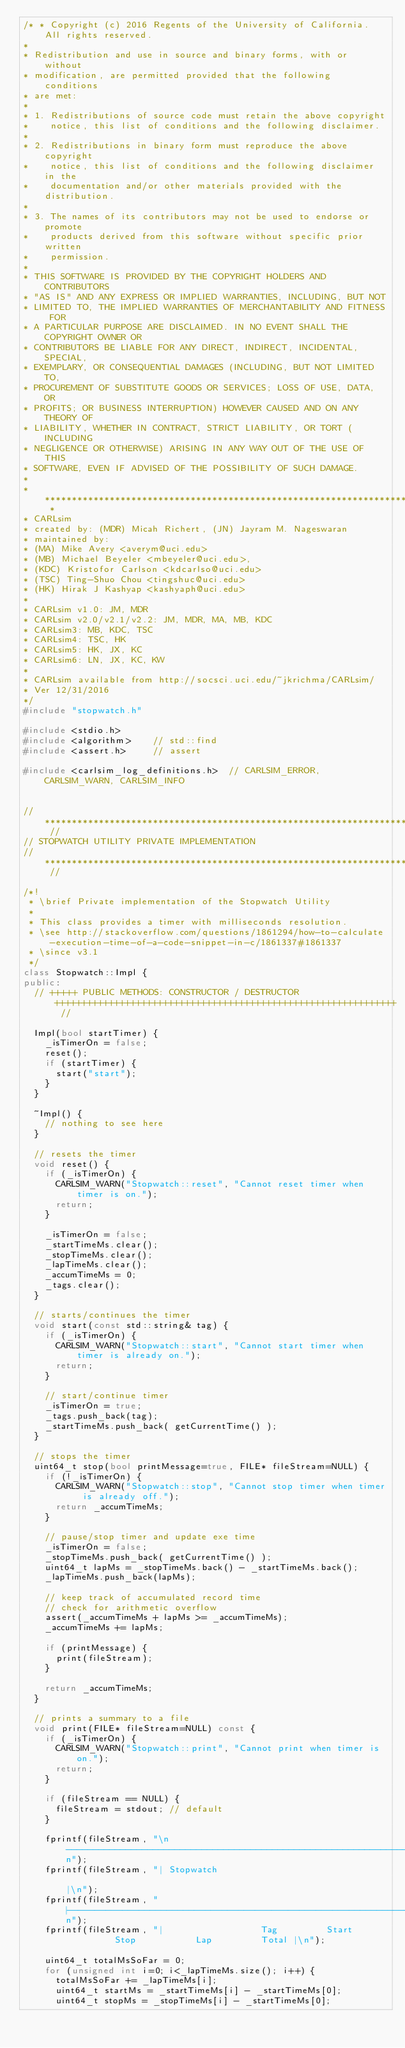Convert code to text. <code><loc_0><loc_0><loc_500><loc_500><_C++_>/* * Copyright (c) 2016 Regents of the University of California. All rights reserved.
*
* Redistribution and use in source and binary forms, with or without
* modification, are permitted provided that the following conditions
* are met:
*
* 1. Redistributions of source code must retain the above copyright
*    notice, this list of conditions and the following disclaimer.
*
* 2. Redistributions in binary form must reproduce the above copyright
*    notice, this list of conditions and the following disclaimer in the
*    documentation and/or other materials provided with the distribution.
*
* 3. The names of its contributors may not be used to endorse or promote
*    products derived from this software without specific prior written
*    permission.
*
* THIS SOFTWARE IS PROVIDED BY THE COPYRIGHT HOLDERS AND CONTRIBUTORS
* "AS IS" AND ANY EXPRESS OR IMPLIED WARRANTIES, INCLUDING, BUT NOT
* LIMITED TO, THE IMPLIED WARRANTIES OF MERCHANTABILITY AND FITNESS FOR
* A PARTICULAR PURPOSE ARE DISCLAIMED. IN NO EVENT SHALL THE COPYRIGHT OWNER OR
* CONTRIBUTORS BE LIABLE FOR ANY DIRECT, INDIRECT, INCIDENTAL, SPECIAL,
* EXEMPLARY, OR CONSEQUENTIAL DAMAGES (INCLUDING, BUT NOT LIMITED TO,
* PROCUREMENT OF SUBSTITUTE GOODS OR SERVICES; LOSS OF USE, DATA, OR
* PROFITS; OR BUSINESS INTERRUPTION) HOWEVER CAUSED AND ON ANY THEORY OF
* LIABILITY, WHETHER IN CONTRACT, STRICT LIABILITY, OR TORT (INCLUDING
* NEGLIGENCE OR OTHERWISE) ARISING IN ANY WAY OUT OF THE USE OF THIS
* SOFTWARE, EVEN IF ADVISED OF THE POSSIBILITY OF SUCH DAMAGE.
*
* *********************************************************************************************** *
* CARLsim
* created by: (MDR) Micah Richert, (JN) Jayram M. Nageswaran
* maintained by:
* (MA) Mike Avery <averym@uci.edu>
* (MB) Michael Beyeler <mbeyeler@uci.edu>,
* (KDC) Kristofor Carlson <kdcarlso@uci.edu>
* (TSC) Ting-Shuo Chou <tingshuc@uci.edu>
* (HK) Hirak J Kashyap <kashyaph@uci.edu>
*
* CARLsim v1.0: JM, MDR
* CARLsim v2.0/v2.1/v2.2: JM, MDR, MA, MB, KDC
* CARLsim3: MB, KDC, TSC
* CARLsim4: TSC, HK
* CARLsim5: HK, JX, KC
* CARLsim6: LN, JX, KC, KW
*
* CARLsim available from http://socsci.uci.edu/~jkrichma/CARLsim/
* Ver 12/31/2016
*/
#include "stopwatch.h"

#include <stdio.h>
#include <algorithm>		// std::find
#include <assert.h>			// assert

#include <carlsim_log_definitions.h>	// CARLSIM_ERROR, CARLSIM_WARN, CARLSIM_INFO


// ****************************************************************************************************************** //
// STOPWATCH UTILITY PRIVATE IMPLEMENTATION
// ****************************************************************************************************************** //

/*!
 * \brief Private implementation of the Stopwatch Utility
 *
 * This class provides a timer with milliseconds resolution.
 * \see http://stackoverflow.com/questions/1861294/how-to-calculate-execution-time-of-a-code-snippet-in-c/1861337#1861337
 * \since v3.1
 */
class Stopwatch::Impl {
public:
	// +++++ PUBLIC METHODS: CONSTRUCTOR / DESTRUCTOR +++++++++++++++++++++++++++++++++++++++++++++++++++++++++++++++ //

	Impl(bool startTimer) {
		_isTimerOn = false;
		reset();
		if (startTimer) {
			start("start");
		}
	}

	~Impl() {
		// nothing to see here
	}

	// resets the timer
	void reset() {
		if (_isTimerOn) {
			CARLSIM_WARN("Stopwatch::reset", "Cannot reset timer when timer is on.");
			return;
		}

		_isTimerOn = false;
		_startTimeMs.clear();
		_stopTimeMs.clear();
		_lapTimeMs.clear();
		_accumTimeMs = 0;
		_tags.clear();
	}

	// starts/continues the timer
	void start(const std::string& tag) {
		if (_isTimerOn) {
			CARLSIM_WARN("Stopwatch::start", "Cannot start timer when timer is already on.");
			return;
		}

		// start/continue timer
		_isTimerOn = true;
		_tags.push_back(tag);
		_startTimeMs.push_back( getCurrentTime() );
	}

	// stops the timer
	uint64_t stop(bool printMessage=true, FILE* fileStream=NULL) {
		if (!_isTimerOn) {
			CARLSIM_WARN("Stopwatch::stop", "Cannot stop timer when timer is already off.");
			return _accumTimeMs;
		}

		// pause/stop timer and update exe time
		_isTimerOn = false;
		_stopTimeMs.push_back( getCurrentTime() );
		uint64_t lapMs = _stopTimeMs.back() - _startTimeMs.back();
		_lapTimeMs.push_back(lapMs);

		// keep track of accumulated record time
		// check for arithmetic overflow
		assert(_accumTimeMs + lapMs >= _accumTimeMs);
		_accumTimeMs += lapMs;

		if (printMessage) {
			print(fileStream);
		}

		return _accumTimeMs;
	}

	// prints a summary to a file
	void print(FILE* fileStream=NULL) const {
		if (_isTimerOn) {
			CARLSIM_WARN("Stopwatch::print", "Cannot print when timer is on.");
			return;
		}

		if (fileStream == NULL) {
			fileStream = stdout; // default
		}

		fprintf(fileStream, "\n--------------------------------------------------------------------------------\n");
		fprintf(fileStream, "| Stopwatch                                                                    |\n");
		fprintf(fileStream, "|------------------------------------------------------------------------------|\n");
		fprintf(fileStream, "|                  Tag         Start          Stop           Lap         Total |\n");

		uint64_t totalMsSoFar = 0;
		for (unsigned int i=0; i<_lapTimeMs.size(); i++) {
			totalMsSoFar += _lapTimeMs[i];
			uint64_t startMs = _startTimeMs[i] - _startTimeMs[0];
			uint64_t stopMs = _stopTimeMs[i] - _startTimeMs[0];</code> 